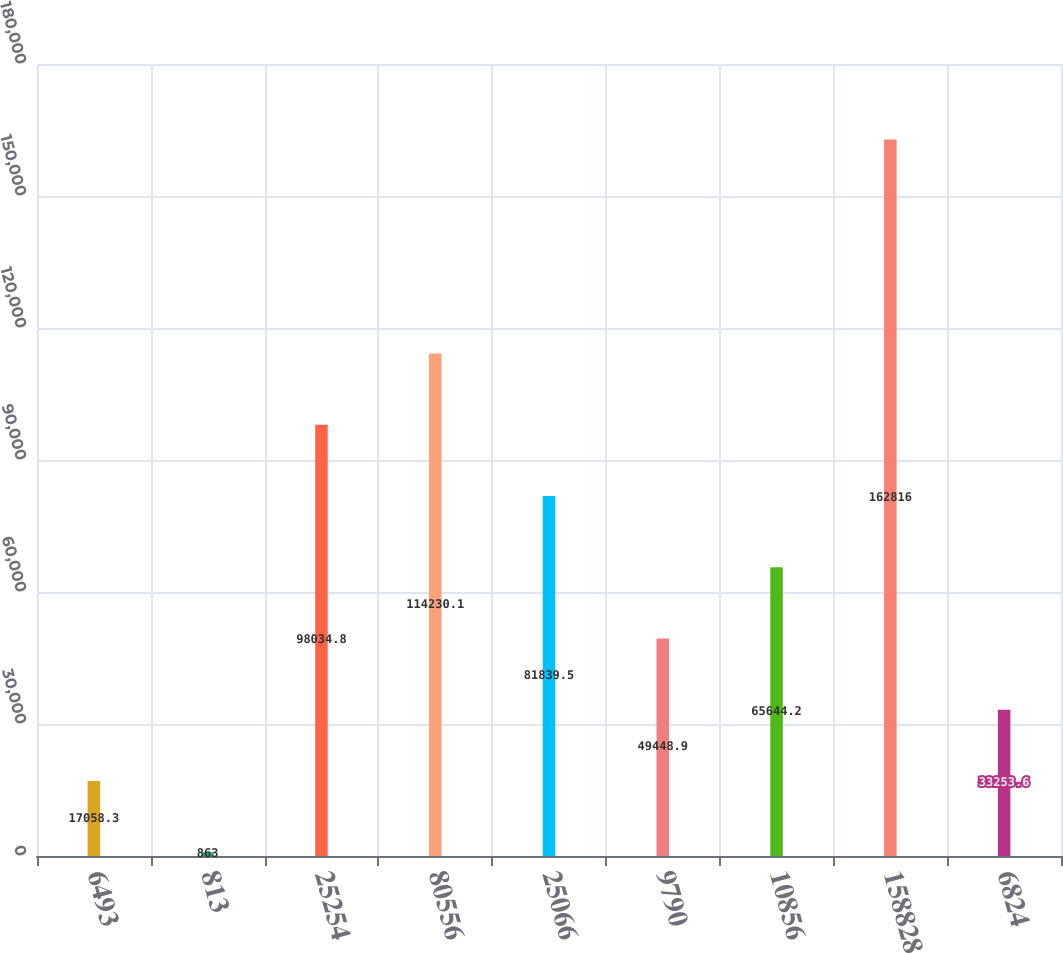Convert chart. <chart><loc_0><loc_0><loc_500><loc_500><bar_chart><fcel>6493<fcel>813<fcel>25254<fcel>80556<fcel>25066<fcel>9790<fcel>10856<fcel>158828<fcel>6824<nl><fcel>17058.3<fcel>863<fcel>98034.8<fcel>114230<fcel>81839.5<fcel>49448.9<fcel>65644.2<fcel>162816<fcel>33253.6<nl></chart> 